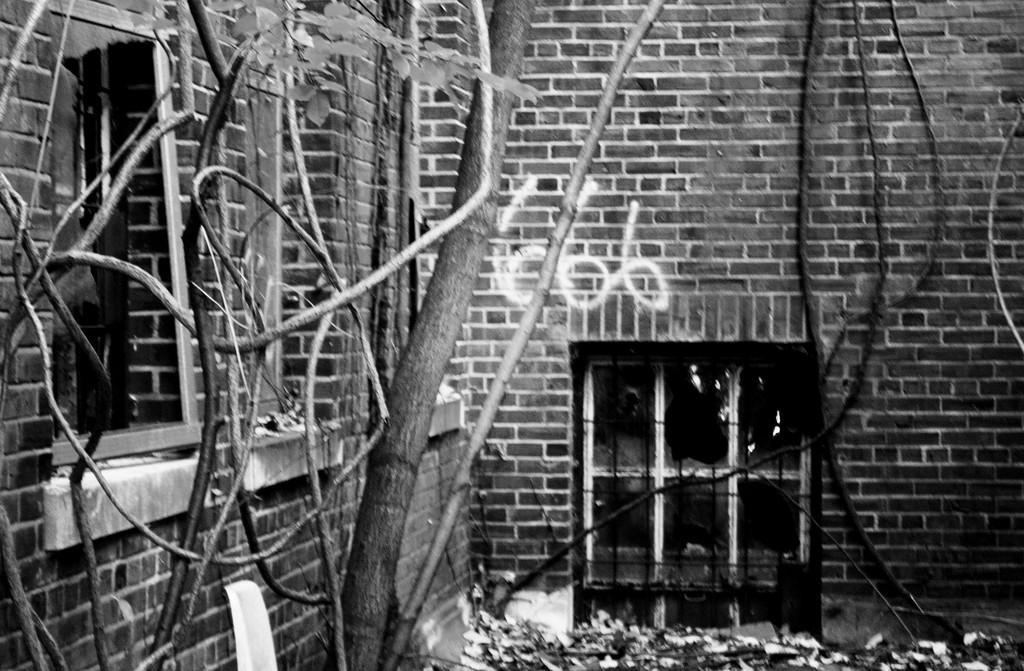What is the color scheme of the image? The image is black and white. What architectural features can be seen in the image? There are windows and a wall in the image. What type of vegetation is present in the image? There is a tree and a creeper in the image. What is visible on the ground in the image? Dried leaves are present on the ground in the image. How many pets are visible in the image? There are no pets visible in the image. What error can be seen in the image? There is no error present in the image. Can you hear anyone laughing in the image? The image is a still photograph, so there is no sound or laughter present. 